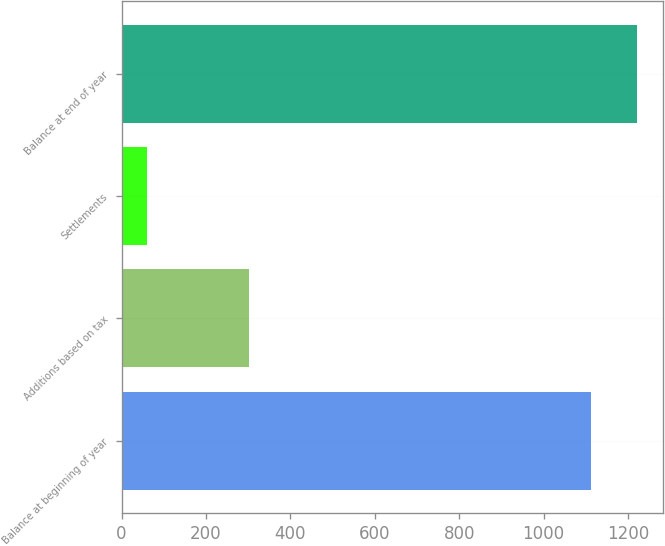<chart> <loc_0><loc_0><loc_500><loc_500><bar_chart><fcel>Balance at beginning of year<fcel>Additions based on tax<fcel>Settlements<fcel>Balance at end of year<nl><fcel>1113<fcel>302<fcel>60<fcel>1221<nl></chart> 